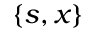<formula> <loc_0><loc_0><loc_500><loc_500>\{ s , x \}</formula> 